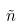Convert formula to latex. <formula><loc_0><loc_0><loc_500><loc_500>\tilde { n }</formula> 